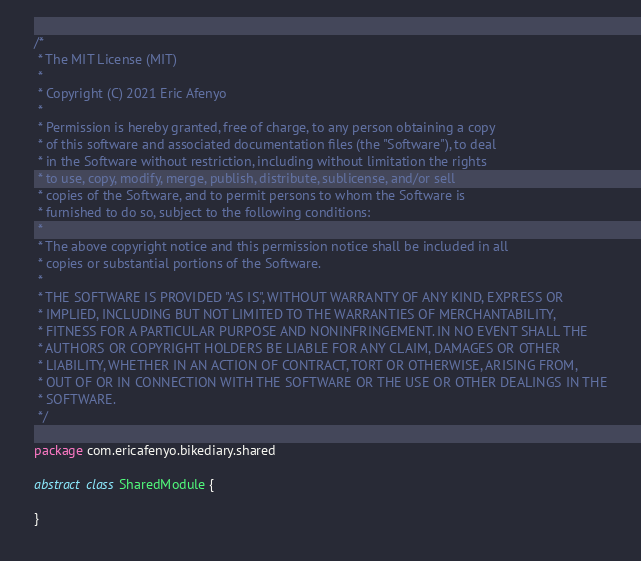Convert code to text. <code><loc_0><loc_0><loc_500><loc_500><_Kotlin_>/*
 * The MIT License (MIT)
 *
 * Copyright (C) 2021 Eric Afenyo
 *
 * Permission is hereby granted, free of charge, to any person obtaining a copy
 * of this software and associated documentation files (the "Software"), to deal
 * in the Software without restriction, including without limitation the rights
 * to use, copy, modify, merge, publish, distribute, sublicense, and/or sell
 * copies of the Software, and to permit persons to whom the Software is
 * furnished to do so, subject to the following conditions:
 *
 * The above copyright notice and this permission notice shall be included in all
 * copies or substantial portions of the Software.
 *
 * THE SOFTWARE IS PROVIDED "AS IS", WITHOUT WARRANTY OF ANY KIND, EXPRESS OR
 * IMPLIED, INCLUDING BUT NOT LIMITED TO THE WARRANTIES OF MERCHANTABILITY,
 * FITNESS FOR A PARTICULAR PURPOSE AND NONINFRINGEMENT. IN NO EVENT SHALL THE
 * AUTHORS OR COPYRIGHT HOLDERS BE LIABLE FOR ANY CLAIM, DAMAGES OR OTHER
 * LIABILITY, WHETHER IN AN ACTION OF CONTRACT, TORT OR OTHERWISE, ARISING FROM,
 * OUT OF OR IN CONNECTION WITH THE SOFTWARE OR THE USE OR OTHER DEALINGS IN THE
 * SOFTWARE.
 */

package com.ericafenyo.bikediary.shared

abstract class SharedModule {

}</code> 